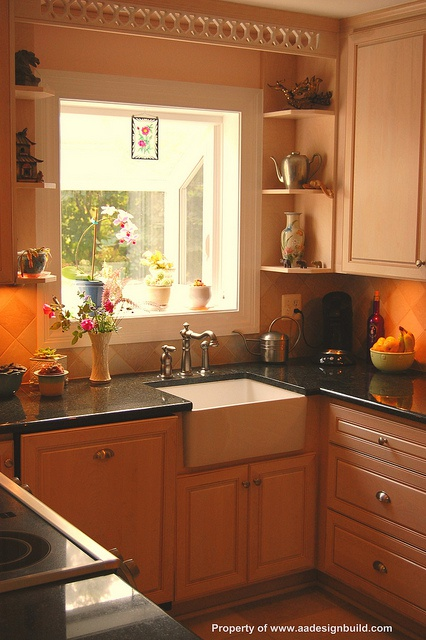Describe the objects in this image and their specific colors. I can see sink in maroon, brown, and tan tones, oven in maroon, black, and tan tones, potted plant in maroon, brown, khaki, beige, and tan tones, potted plant in maroon, beige, olive, khaki, and gray tones, and potted plant in maroon, khaki, lightyellow, and tan tones in this image. 